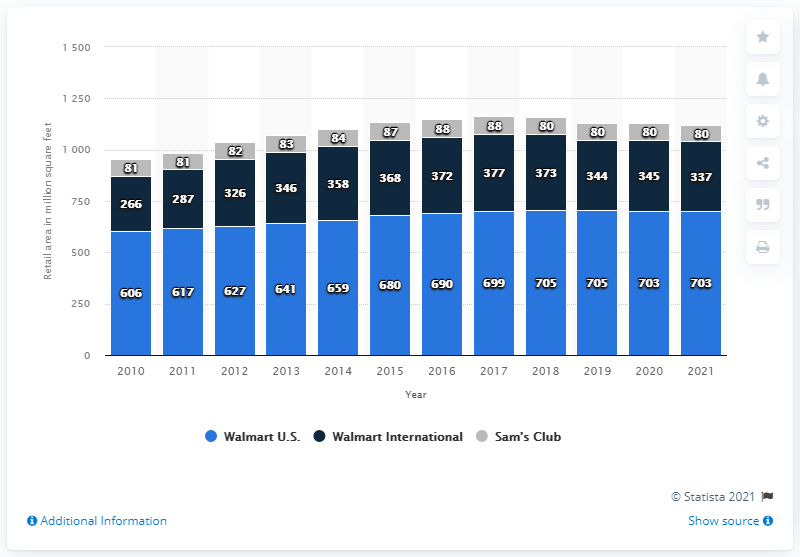Outline some significant characteristics in this image. As of January 31st, 2021, Walmart U.S. had a total retail sales area of approximately 703 square feet. As of January 31, 2021, Walmart International's sales area was 337. 